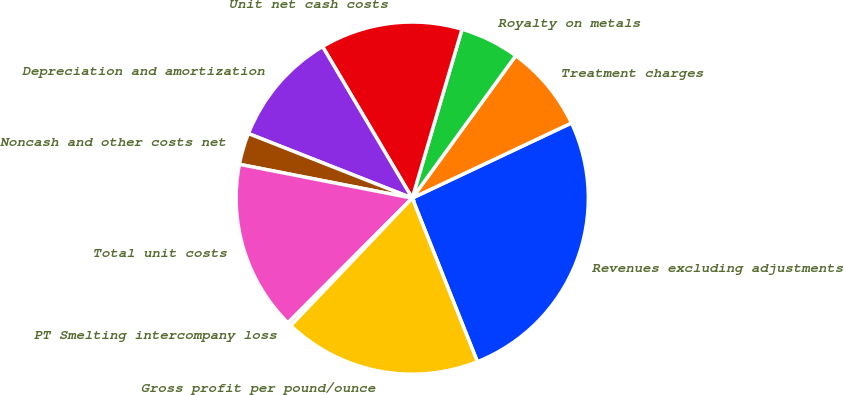<chart> <loc_0><loc_0><loc_500><loc_500><pie_chart><fcel>Revenues excluding adjustments<fcel>Treatment charges<fcel>Royalty on metals<fcel>Unit net cash costs<fcel>Depreciation and amortization<fcel>Noncash and other costs net<fcel>Total unit costs<fcel>PT Smelting intercompany loss<fcel>Gross profit per pound/ounce<nl><fcel>25.98%<fcel>7.98%<fcel>5.44%<fcel>13.06%<fcel>10.52%<fcel>2.9%<fcel>15.6%<fcel>0.36%<fcel>18.14%<nl></chart> 